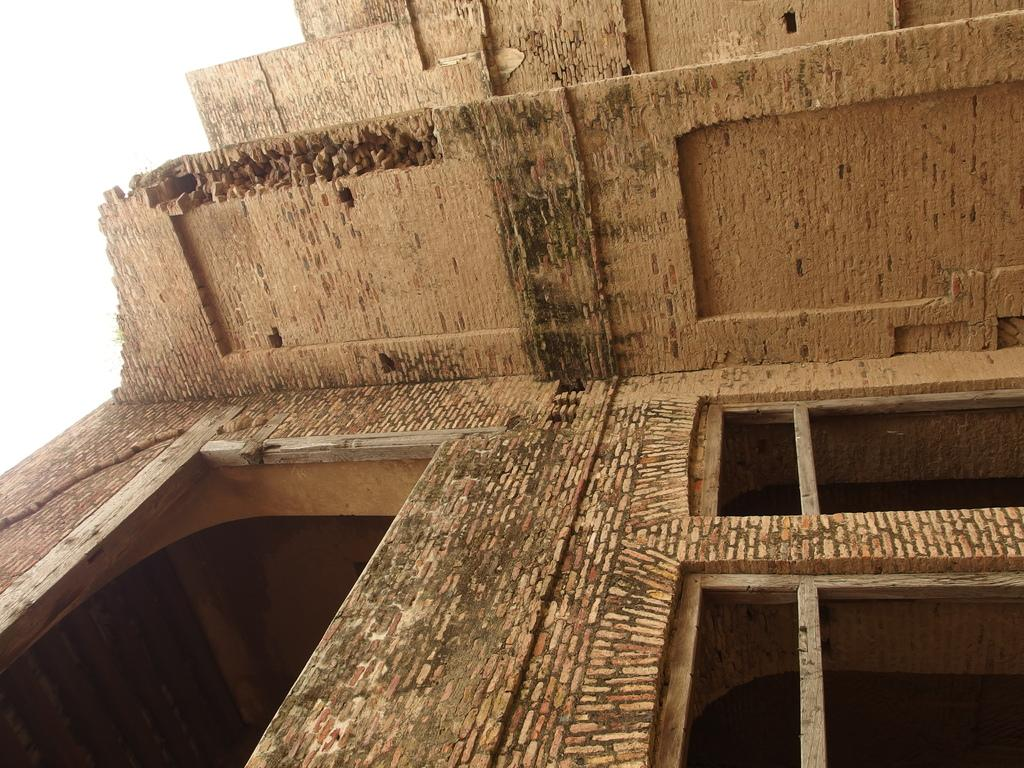What is the main subject of the image? There is a building in the image. What color is the background of the image? The background of the image is white. What type of jelly can be seen on the building in the image? There is no jelly present on the building in the image. How does the sock contribute to the image's overall theme? There is no sock present in the image, so it cannot contribute to the image's overall theme. 